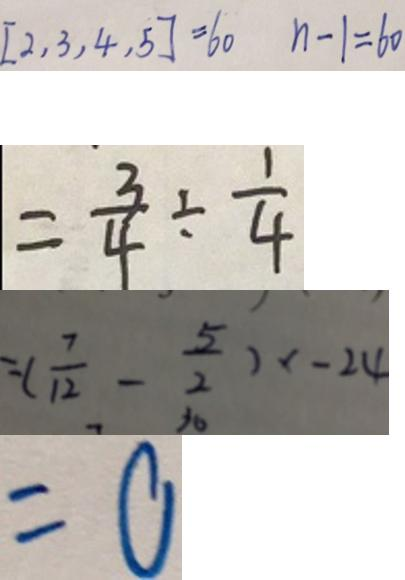Convert formula to latex. <formula><loc_0><loc_0><loc_500><loc_500>[ 2 , 3 , 4 , 5 ] = 6 0 n - 1 = 6 0 
 = \frac { 3 } { 4 } \div \frac { 1 } { 4 } 
 = ( \frac { 7 } { 1 2 } - \frac { 5 } { 2 } ) x - 2 4 
 = 0</formula> 